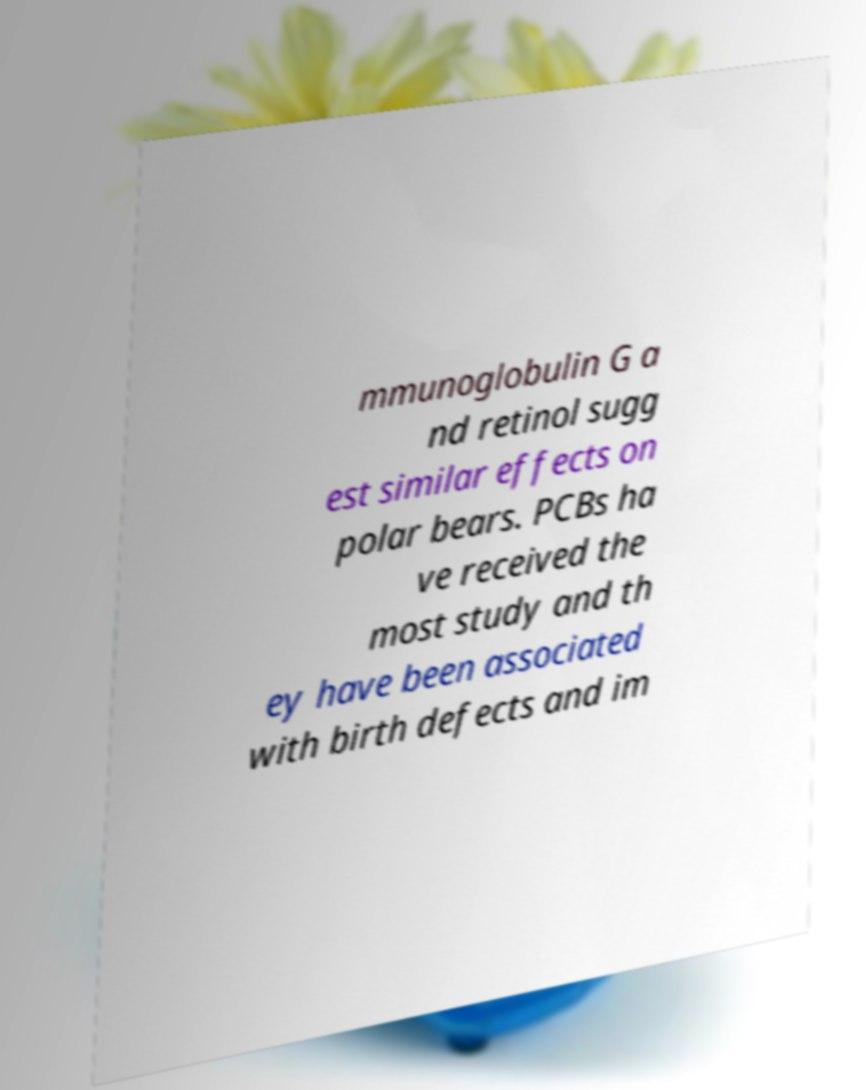What messages or text are displayed in this image? I need them in a readable, typed format. mmunoglobulin G a nd retinol sugg est similar effects on polar bears. PCBs ha ve received the most study and th ey have been associated with birth defects and im 